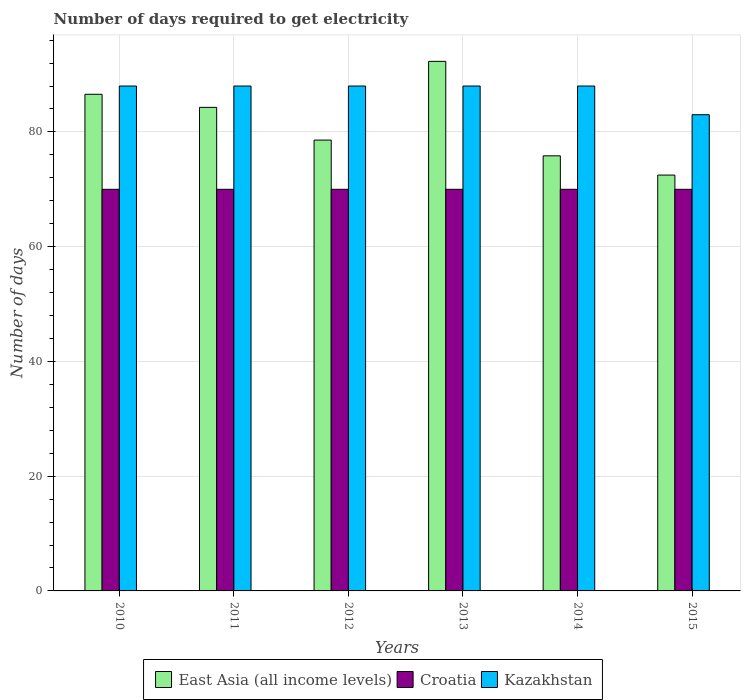How many different coloured bars are there?
Give a very brief answer. 3. Are the number of bars per tick equal to the number of legend labels?
Your answer should be very brief. Yes. What is the label of the 5th group of bars from the left?
Your answer should be very brief. 2014. What is the number of days required to get electricity in in East Asia (all income levels) in 2011?
Your answer should be compact. 84.28. Across all years, what is the maximum number of days required to get electricity in in Croatia?
Ensure brevity in your answer.  70. Across all years, what is the minimum number of days required to get electricity in in East Asia (all income levels)?
Your answer should be very brief. 72.48. In which year was the number of days required to get electricity in in East Asia (all income levels) maximum?
Offer a terse response. 2013. In which year was the number of days required to get electricity in in Croatia minimum?
Ensure brevity in your answer.  2010. What is the total number of days required to get electricity in in Kazakhstan in the graph?
Offer a terse response. 523. What is the difference between the number of days required to get electricity in in Croatia in 2012 and that in 2014?
Your answer should be compact. 0. What is the difference between the number of days required to get electricity in in Kazakhstan in 2010 and the number of days required to get electricity in in East Asia (all income levels) in 2012?
Provide a short and direct response. 9.42. What is the average number of days required to get electricity in in Croatia per year?
Your answer should be very brief. 70. In the year 2014, what is the difference between the number of days required to get electricity in in Croatia and number of days required to get electricity in in East Asia (all income levels)?
Keep it short and to the point. -5.83. In how many years, is the number of days required to get electricity in in Croatia greater than 12 days?
Offer a very short reply. 6. What is the ratio of the number of days required to get electricity in in East Asia (all income levels) in 2013 to that in 2015?
Your answer should be very brief. 1.27. Is the number of days required to get electricity in in East Asia (all income levels) in 2010 less than that in 2015?
Offer a terse response. No. What is the difference between the highest and the lowest number of days required to get electricity in in East Asia (all income levels)?
Give a very brief answer. 19.82. Is the sum of the number of days required to get electricity in in East Asia (all income levels) in 2013 and 2014 greater than the maximum number of days required to get electricity in in Croatia across all years?
Offer a terse response. Yes. What does the 3rd bar from the left in 2011 represents?
Your response must be concise. Kazakhstan. What does the 1st bar from the right in 2015 represents?
Offer a terse response. Kazakhstan. How many bars are there?
Ensure brevity in your answer.  18. How many years are there in the graph?
Offer a terse response. 6. Does the graph contain grids?
Your response must be concise. Yes. How many legend labels are there?
Ensure brevity in your answer.  3. How are the legend labels stacked?
Make the answer very short. Horizontal. What is the title of the graph?
Give a very brief answer. Number of days required to get electricity. Does "Low & middle income" appear as one of the legend labels in the graph?
Your answer should be very brief. No. What is the label or title of the X-axis?
Offer a very short reply. Years. What is the label or title of the Y-axis?
Your answer should be compact. Number of days. What is the Number of days of East Asia (all income levels) in 2010?
Give a very brief answer. 86.56. What is the Number of days in East Asia (all income levels) in 2011?
Make the answer very short. 84.28. What is the Number of days of Croatia in 2011?
Provide a succinct answer. 70. What is the Number of days in East Asia (all income levels) in 2012?
Ensure brevity in your answer.  78.58. What is the Number of days of East Asia (all income levels) in 2013?
Ensure brevity in your answer.  92.3. What is the Number of days of Croatia in 2013?
Your response must be concise. 70. What is the Number of days in Kazakhstan in 2013?
Ensure brevity in your answer.  88. What is the Number of days of East Asia (all income levels) in 2014?
Offer a terse response. 75.83. What is the Number of days of East Asia (all income levels) in 2015?
Give a very brief answer. 72.48. What is the Number of days in Croatia in 2015?
Provide a short and direct response. 70. Across all years, what is the maximum Number of days in East Asia (all income levels)?
Keep it short and to the point. 92.3. Across all years, what is the maximum Number of days in Kazakhstan?
Keep it short and to the point. 88. Across all years, what is the minimum Number of days in East Asia (all income levels)?
Your answer should be compact. 72.48. Across all years, what is the minimum Number of days of Kazakhstan?
Make the answer very short. 83. What is the total Number of days of East Asia (all income levels) in the graph?
Ensure brevity in your answer.  490.03. What is the total Number of days of Croatia in the graph?
Give a very brief answer. 420. What is the total Number of days of Kazakhstan in the graph?
Your answer should be very brief. 523. What is the difference between the Number of days of East Asia (all income levels) in 2010 and that in 2011?
Ensure brevity in your answer.  2.28. What is the difference between the Number of days in Croatia in 2010 and that in 2011?
Your response must be concise. 0. What is the difference between the Number of days in Kazakhstan in 2010 and that in 2011?
Make the answer very short. 0. What is the difference between the Number of days of East Asia (all income levels) in 2010 and that in 2012?
Keep it short and to the point. 7.98. What is the difference between the Number of days of Croatia in 2010 and that in 2012?
Give a very brief answer. 0. What is the difference between the Number of days of Kazakhstan in 2010 and that in 2012?
Your answer should be very brief. 0. What is the difference between the Number of days of East Asia (all income levels) in 2010 and that in 2013?
Ensure brevity in your answer.  -5.74. What is the difference between the Number of days in Croatia in 2010 and that in 2013?
Your answer should be very brief. 0. What is the difference between the Number of days in East Asia (all income levels) in 2010 and that in 2014?
Provide a short and direct response. 10.73. What is the difference between the Number of days of East Asia (all income levels) in 2010 and that in 2015?
Ensure brevity in your answer.  14.08. What is the difference between the Number of days in Croatia in 2010 and that in 2015?
Keep it short and to the point. 0. What is the difference between the Number of days of Kazakhstan in 2010 and that in 2015?
Ensure brevity in your answer.  5. What is the difference between the Number of days in East Asia (all income levels) in 2011 and that in 2012?
Make the answer very short. 5.7. What is the difference between the Number of days of Croatia in 2011 and that in 2012?
Provide a short and direct response. 0. What is the difference between the Number of days of Kazakhstan in 2011 and that in 2012?
Keep it short and to the point. 0. What is the difference between the Number of days in East Asia (all income levels) in 2011 and that in 2013?
Offer a terse response. -8.02. What is the difference between the Number of days in Croatia in 2011 and that in 2013?
Your response must be concise. 0. What is the difference between the Number of days of Kazakhstan in 2011 and that in 2013?
Provide a short and direct response. 0. What is the difference between the Number of days of East Asia (all income levels) in 2011 and that in 2014?
Give a very brief answer. 8.45. What is the difference between the Number of days of Kazakhstan in 2011 and that in 2014?
Offer a very short reply. 0. What is the difference between the Number of days in East Asia (all income levels) in 2011 and that in 2015?
Your answer should be very brief. 11.8. What is the difference between the Number of days of East Asia (all income levels) in 2012 and that in 2013?
Ensure brevity in your answer.  -13.72. What is the difference between the Number of days in Kazakhstan in 2012 and that in 2013?
Provide a succinct answer. 0. What is the difference between the Number of days in East Asia (all income levels) in 2012 and that in 2014?
Offer a very short reply. 2.74. What is the difference between the Number of days of Kazakhstan in 2012 and that in 2014?
Give a very brief answer. 0. What is the difference between the Number of days of East Asia (all income levels) in 2012 and that in 2015?
Provide a short and direct response. 6.1. What is the difference between the Number of days of East Asia (all income levels) in 2013 and that in 2014?
Your answer should be very brief. 16.47. What is the difference between the Number of days in Croatia in 2013 and that in 2014?
Your response must be concise. 0. What is the difference between the Number of days in Kazakhstan in 2013 and that in 2014?
Your response must be concise. 0. What is the difference between the Number of days of East Asia (all income levels) in 2013 and that in 2015?
Make the answer very short. 19.82. What is the difference between the Number of days in Croatia in 2013 and that in 2015?
Provide a short and direct response. 0. What is the difference between the Number of days of Kazakhstan in 2013 and that in 2015?
Your answer should be compact. 5. What is the difference between the Number of days in East Asia (all income levels) in 2014 and that in 2015?
Give a very brief answer. 3.36. What is the difference between the Number of days in Croatia in 2014 and that in 2015?
Keep it short and to the point. 0. What is the difference between the Number of days of Kazakhstan in 2014 and that in 2015?
Provide a short and direct response. 5. What is the difference between the Number of days in East Asia (all income levels) in 2010 and the Number of days in Croatia in 2011?
Keep it short and to the point. 16.56. What is the difference between the Number of days of East Asia (all income levels) in 2010 and the Number of days of Kazakhstan in 2011?
Offer a very short reply. -1.44. What is the difference between the Number of days in East Asia (all income levels) in 2010 and the Number of days in Croatia in 2012?
Provide a short and direct response. 16.56. What is the difference between the Number of days in East Asia (all income levels) in 2010 and the Number of days in Kazakhstan in 2012?
Give a very brief answer. -1.44. What is the difference between the Number of days of Croatia in 2010 and the Number of days of Kazakhstan in 2012?
Your answer should be very brief. -18. What is the difference between the Number of days in East Asia (all income levels) in 2010 and the Number of days in Croatia in 2013?
Ensure brevity in your answer.  16.56. What is the difference between the Number of days in East Asia (all income levels) in 2010 and the Number of days in Kazakhstan in 2013?
Provide a short and direct response. -1.44. What is the difference between the Number of days of East Asia (all income levels) in 2010 and the Number of days of Croatia in 2014?
Give a very brief answer. 16.56. What is the difference between the Number of days of East Asia (all income levels) in 2010 and the Number of days of Kazakhstan in 2014?
Make the answer very short. -1.44. What is the difference between the Number of days in Croatia in 2010 and the Number of days in Kazakhstan in 2014?
Make the answer very short. -18. What is the difference between the Number of days in East Asia (all income levels) in 2010 and the Number of days in Croatia in 2015?
Give a very brief answer. 16.56. What is the difference between the Number of days of East Asia (all income levels) in 2010 and the Number of days of Kazakhstan in 2015?
Your answer should be very brief. 3.56. What is the difference between the Number of days of Croatia in 2010 and the Number of days of Kazakhstan in 2015?
Keep it short and to the point. -13. What is the difference between the Number of days in East Asia (all income levels) in 2011 and the Number of days in Croatia in 2012?
Offer a very short reply. 14.28. What is the difference between the Number of days in East Asia (all income levels) in 2011 and the Number of days in Kazakhstan in 2012?
Ensure brevity in your answer.  -3.72. What is the difference between the Number of days of Croatia in 2011 and the Number of days of Kazakhstan in 2012?
Offer a very short reply. -18. What is the difference between the Number of days in East Asia (all income levels) in 2011 and the Number of days in Croatia in 2013?
Give a very brief answer. 14.28. What is the difference between the Number of days in East Asia (all income levels) in 2011 and the Number of days in Kazakhstan in 2013?
Ensure brevity in your answer.  -3.72. What is the difference between the Number of days in East Asia (all income levels) in 2011 and the Number of days in Croatia in 2014?
Provide a short and direct response. 14.28. What is the difference between the Number of days in East Asia (all income levels) in 2011 and the Number of days in Kazakhstan in 2014?
Offer a very short reply. -3.72. What is the difference between the Number of days of Croatia in 2011 and the Number of days of Kazakhstan in 2014?
Give a very brief answer. -18. What is the difference between the Number of days in East Asia (all income levels) in 2011 and the Number of days in Croatia in 2015?
Provide a short and direct response. 14.28. What is the difference between the Number of days of East Asia (all income levels) in 2011 and the Number of days of Kazakhstan in 2015?
Give a very brief answer. 1.28. What is the difference between the Number of days in Croatia in 2011 and the Number of days in Kazakhstan in 2015?
Your answer should be very brief. -13. What is the difference between the Number of days in East Asia (all income levels) in 2012 and the Number of days in Croatia in 2013?
Your response must be concise. 8.58. What is the difference between the Number of days of East Asia (all income levels) in 2012 and the Number of days of Kazakhstan in 2013?
Your answer should be very brief. -9.42. What is the difference between the Number of days in East Asia (all income levels) in 2012 and the Number of days in Croatia in 2014?
Offer a terse response. 8.58. What is the difference between the Number of days in East Asia (all income levels) in 2012 and the Number of days in Kazakhstan in 2014?
Your answer should be very brief. -9.42. What is the difference between the Number of days of East Asia (all income levels) in 2012 and the Number of days of Croatia in 2015?
Offer a very short reply. 8.58. What is the difference between the Number of days in East Asia (all income levels) in 2012 and the Number of days in Kazakhstan in 2015?
Make the answer very short. -4.42. What is the difference between the Number of days of Croatia in 2012 and the Number of days of Kazakhstan in 2015?
Offer a very short reply. -13. What is the difference between the Number of days of East Asia (all income levels) in 2013 and the Number of days of Croatia in 2014?
Provide a short and direct response. 22.3. What is the difference between the Number of days in East Asia (all income levels) in 2013 and the Number of days in Croatia in 2015?
Provide a short and direct response. 22.3. What is the difference between the Number of days in Croatia in 2013 and the Number of days in Kazakhstan in 2015?
Offer a terse response. -13. What is the difference between the Number of days in East Asia (all income levels) in 2014 and the Number of days in Croatia in 2015?
Your response must be concise. 5.83. What is the difference between the Number of days of East Asia (all income levels) in 2014 and the Number of days of Kazakhstan in 2015?
Make the answer very short. -7.17. What is the difference between the Number of days of Croatia in 2014 and the Number of days of Kazakhstan in 2015?
Provide a succinct answer. -13. What is the average Number of days in East Asia (all income levels) per year?
Your response must be concise. 81.67. What is the average Number of days in Croatia per year?
Your response must be concise. 70. What is the average Number of days of Kazakhstan per year?
Your response must be concise. 87.17. In the year 2010, what is the difference between the Number of days in East Asia (all income levels) and Number of days in Croatia?
Provide a succinct answer. 16.56. In the year 2010, what is the difference between the Number of days of East Asia (all income levels) and Number of days of Kazakhstan?
Your response must be concise. -1.44. In the year 2011, what is the difference between the Number of days in East Asia (all income levels) and Number of days in Croatia?
Offer a very short reply. 14.28. In the year 2011, what is the difference between the Number of days in East Asia (all income levels) and Number of days in Kazakhstan?
Your answer should be very brief. -3.72. In the year 2011, what is the difference between the Number of days in Croatia and Number of days in Kazakhstan?
Make the answer very short. -18. In the year 2012, what is the difference between the Number of days in East Asia (all income levels) and Number of days in Croatia?
Your answer should be compact. 8.58. In the year 2012, what is the difference between the Number of days in East Asia (all income levels) and Number of days in Kazakhstan?
Your answer should be compact. -9.42. In the year 2013, what is the difference between the Number of days of East Asia (all income levels) and Number of days of Croatia?
Make the answer very short. 22.3. In the year 2014, what is the difference between the Number of days in East Asia (all income levels) and Number of days in Croatia?
Provide a succinct answer. 5.83. In the year 2014, what is the difference between the Number of days of East Asia (all income levels) and Number of days of Kazakhstan?
Offer a very short reply. -12.17. In the year 2015, what is the difference between the Number of days of East Asia (all income levels) and Number of days of Croatia?
Ensure brevity in your answer.  2.48. In the year 2015, what is the difference between the Number of days in East Asia (all income levels) and Number of days in Kazakhstan?
Offer a very short reply. -10.52. In the year 2015, what is the difference between the Number of days in Croatia and Number of days in Kazakhstan?
Provide a short and direct response. -13. What is the ratio of the Number of days of East Asia (all income levels) in 2010 to that in 2011?
Offer a very short reply. 1.03. What is the ratio of the Number of days of East Asia (all income levels) in 2010 to that in 2012?
Offer a very short reply. 1.1. What is the ratio of the Number of days in East Asia (all income levels) in 2010 to that in 2013?
Offer a terse response. 0.94. What is the ratio of the Number of days in Kazakhstan in 2010 to that in 2013?
Offer a terse response. 1. What is the ratio of the Number of days of East Asia (all income levels) in 2010 to that in 2014?
Offer a very short reply. 1.14. What is the ratio of the Number of days in Croatia in 2010 to that in 2014?
Give a very brief answer. 1. What is the ratio of the Number of days in East Asia (all income levels) in 2010 to that in 2015?
Provide a short and direct response. 1.19. What is the ratio of the Number of days of Kazakhstan in 2010 to that in 2015?
Provide a succinct answer. 1.06. What is the ratio of the Number of days in East Asia (all income levels) in 2011 to that in 2012?
Ensure brevity in your answer.  1.07. What is the ratio of the Number of days in East Asia (all income levels) in 2011 to that in 2013?
Your response must be concise. 0.91. What is the ratio of the Number of days in Croatia in 2011 to that in 2013?
Provide a succinct answer. 1. What is the ratio of the Number of days in East Asia (all income levels) in 2011 to that in 2014?
Keep it short and to the point. 1.11. What is the ratio of the Number of days of Croatia in 2011 to that in 2014?
Your response must be concise. 1. What is the ratio of the Number of days in Kazakhstan in 2011 to that in 2014?
Keep it short and to the point. 1. What is the ratio of the Number of days in East Asia (all income levels) in 2011 to that in 2015?
Provide a short and direct response. 1.16. What is the ratio of the Number of days of Croatia in 2011 to that in 2015?
Your answer should be compact. 1. What is the ratio of the Number of days of Kazakhstan in 2011 to that in 2015?
Provide a succinct answer. 1.06. What is the ratio of the Number of days in East Asia (all income levels) in 2012 to that in 2013?
Ensure brevity in your answer.  0.85. What is the ratio of the Number of days of Croatia in 2012 to that in 2013?
Provide a succinct answer. 1. What is the ratio of the Number of days of East Asia (all income levels) in 2012 to that in 2014?
Provide a succinct answer. 1.04. What is the ratio of the Number of days of Kazakhstan in 2012 to that in 2014?
Provide a short and direct response. 1. What is the ratio of the Number of days in East Asia (all income levels) in 2012 to that in 2015?
Offer a terse response. 1.08. What is the ratio of the Number of days of Kazakhstan in 2012 to that in 2015?
Ensure brevity in your answer.  1.06. What is the ratio of the Number of days in East Asia (all income levels) in 2013 to that in 2014?
Make the answer very short. 1.22. What is the ratio of the Number of days of Croatia in 2013 to that in 2014?
Offer a very short reply. 1. What is the ratio of the Number of days of East Asia (all income levels) in 2013 to that in 2015?
Your answer should be very brief. 1.27. What is the ratio of the Number of days in Kazakhstan in 2013 to that in 2015?
Your response must be concise. 1.06. What is the ratio of the Number of days in East Asia (all income levels) in 2014 to that in 2015?
Offer a very short reply. 1.05. What is the ratio of the Number of days in Croatia in 2014 to that in 2015?
Provide a short and direct response. 1. What is the ratio of the Number of days in Kazakhstan in 2014 to that in 2015?
Provide a short and direct response. 1.06. What is the difference between the highest and the second highest Number of days in East Asia (all income levels)?
Keep it short and to the point. 5.74. What is the difference between the highest and the lowest Number of days of East Asia (all income levels)?
Ensure brevity in your answer.  19.82. What is the difference between the highest and the lowest Number of days in Croatia?
Your answer should be compact. 0. 